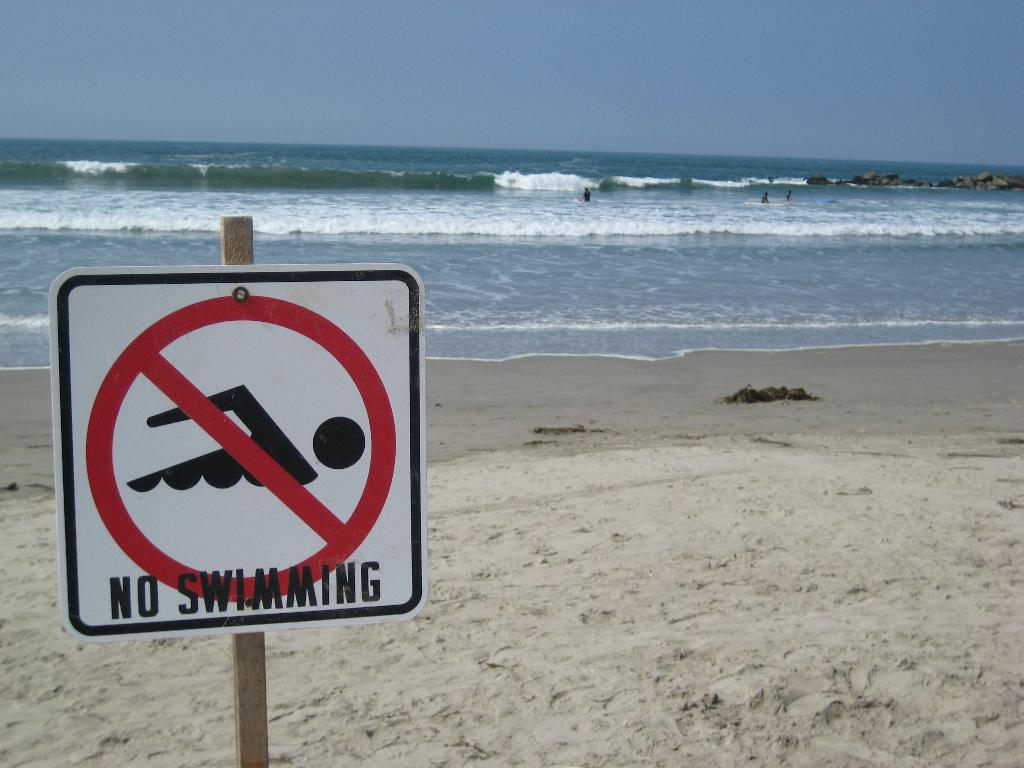Provide a one-sentence caption for the provided image. A signpost is in the sand before a choppy sea which forbids swimming. 